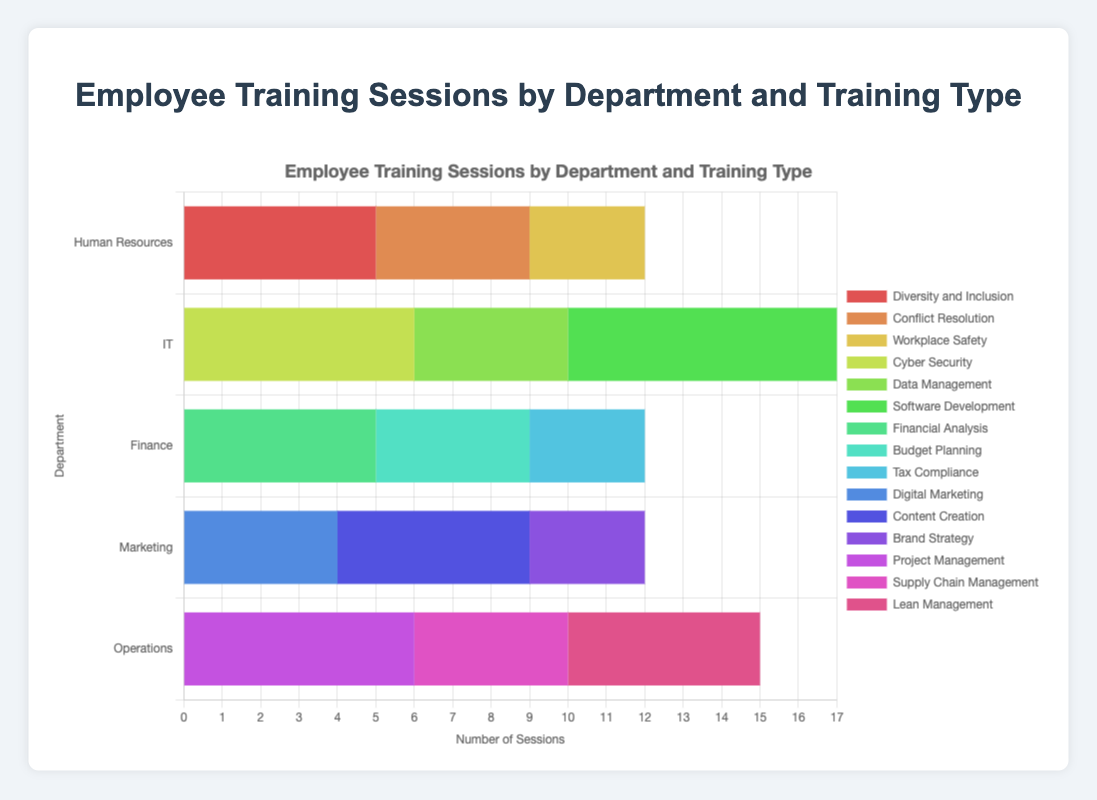Which department has the most training sessions overall? Add up the sessions for each department: Human Resources (5 + 4 + 3 = 12), IT (6 + 4 + 7 = 17), Finance (5 + 4 + 3 = 12), Marketing (4 + 5 + 3 = 12), Operations (6 + 4 + 5 = 15). IT has the highest total.
Answer: IT Which training type in Human Resources has the fewest sessions? Look at the values for Human Resources: Diversity and Inclusion (5), Conflict Resolution (4), Workplace Safety (3). The fewest is for Workplace Safety.
Answer: Workplace Safety Which department offers the highest number of sessions for a single training type? Compare the highest sessions for each department: Human Resources (5 for Diversity and Inclusion), IT (7 for Software Development), Finance (5 for Financial Analysis), Marketing (5 for Content Creation), Operations (6 for Project Management). IT with Software Development has the highest.
Answer: IT with Software Development How do the total training sessions for IT compare to those for Operations? Total the sessions for each department: IT (6 + 4 + 7 = 17), Operations (6 + 4 + 5 = 15). IT has 2 more sessions than Operations.
Answer: IT has 2 more sessions Which departments have training types with an equal number of sessions? Compare sessions across departments: Human Resources and Finance both have 5 sessions (Diversity and Inclusion, Financial Analysis). Marketing and Finance both have 5 sessions (Content Creation, Financial Analysis). Only after cross-comparisons, see if any match precisely.
Answer: Human Resources and Finance, Marketing and Finance What's the total number of training sessions for Diversity and Inclusion across all departments? Sum up sessions for Diversity and Inclusion in each department: Human Resources (5). No other departments have this type of training.
Answer: 5 What is the average number of sessions per training type in the Finance department? Finance data: Financial Analysis (5), Budget Planning (4), Tax Compliance (3). Sum: 5 + 4 + 3 = 12. Average: 12/3 = 4.
Answer: 4 Which training type has the most variety across departments? Check training types offered by multiple departments. Cyber Security, Conflict Resolution, Diversity and Inclusion, Data Management, Software Development (IT), Financial Analysis, Budget Planning, Tax Compliance (Finance), Digital Marketing, Content Creation, Brand Strategy (Marketing), Project Management, Supply Chain Management, Lean Management (Operations). None repeat across departments so no single type dominates in variety.
Answer: None 